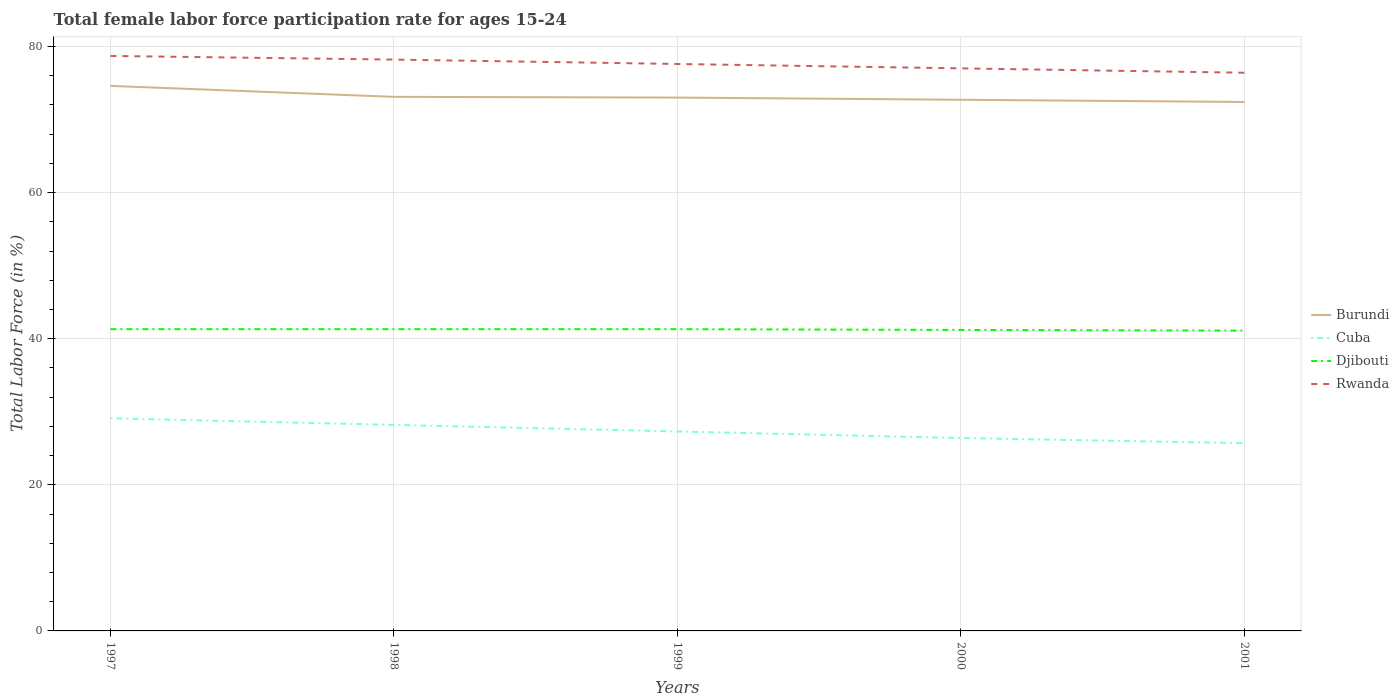Does the line corresponding to Cuba intersect with the line corresponding to Rwanda?
Ensure brevity in your answer.  No. Across all years, what is the maximum female labor force participation rate in Rwanda?
Give a very brief answer. 76.4. What is the total female labor force participation rate in Djibouti in the graph?
Offer a very short reply. 0.1. What is the difference between the highest and the second highest female labor force participation rate in Djibouti?
Give a very brief answer. 0.2. What is the difference between the highest and the lowest female labor force participation rate in Burundi?
Your answer should be very brief. 1. How many years are there in the graph?
Give a very brief answer. 5. Are the values on the major ticks of Y-axis written in scientific E-notation?
Provide a short and direct response. No. Does the graph contain grids?
Provide a short and direct response. Yes. How are the legend labels stacked?
Make the answer very short. Vertical. What is the title of the graph?
Your answer should be compact. Total female labor force participation rate for ages 15-24. Does "Ecuador" appear as one of the legend labels in the graph?
Provide a short and direct response. No. What is the label or title of the X-axis?
Your response must be concise. Years. What is the Total Labor Force (in %) in Burundi in 1997?
Keep it short and to the point. 74.6. What is the Total Labor Force (in %) of Cuba in 1997?
Offer a very short reply. 29.1. What is the Total Labor Force (in %) in Djibouti in 1997?
Provide a short and direct response. 41.3. What is the Total Labor Force (in %) in Rwanda in 1997?
Give a very brief answer. 78.7. What is the Total Labor Force (in %) in Burundi in 1998?
Your answer should be very brief. 73.1. What is the Total Labor Force (in %) of Cuba in 1998?
Keep it short and to the point. 28.2. What is the Total Labor Force (in %) of Djibouti in 1998?
Make the answer very short. 41.3. What is the Total Labor Force (in %) of Rwanda in 1998?
Make the answer very short. 78.2. What is the Total Labor Force (in %) in Burundi in 1999?
Provide a short and direct response. 73. What is the Total Labor Force (in %) of Cuba in 1999?
Provide a succinct answer. 27.3. What is the Total Labor Force (in %) in Djibouti in 1999?
Your answer should be compact. 41.3. What is the Total Labor Force (in %) in Rwanda in 1999?
Offer a terse response. 77.6. What is the Total Labor Force (in %) in Burundi in 2000?
Provide a short and direct response. 72.7. What is the Total Labor Force (in %) of Cuba in 2000?
Make the answer very short. 26.4. What is the Total Labor Force (in %) in Djibouti in 2000?
Your answer should be very brief. 41.2. What is the Total Labor Force (in %) of Rwanda in 2000?
Give a very brief answer. 77. What is the Total Labor Force (in %) in Burundi in 2001?
Your response must be concise. 72.4. What is the Total Labor Force (in %) in Cuba in 2001?
Give a very brief answer. 25.7. What is the Total Labor Force (in %) in Djibouti in 2001?
Provide a short and direct response. 41.1. What is the Total Labor Force (in %) of Rwanda in 2001?
Give a very brief answer. 76.4. Across all years, what is the maximum Total Labor Force (in %) of Burundi?
Give a very brief answer. 74.6. Across all years, what is the maximum Total Labor Force (in %) in Cuba?
Offer a very short reply. 29.1. Across all years, what is the maximum Total Labor Force (in %) in Djibouti?
Your answer should be compact. 41.3. Across all years, what is the maximum Total Labor Force (in %) in Rwanda?
Make the answer very short. 78.7. Across all years, what is the minimum Total Labor Force (in %) in Burundi?
Provide a succinct answer. 72.4. Across all years, what is the minimum Total Labor Force (in %) of Cuba?
Keep it short and to the point. 25.7. Across all years, what is the minimum Total Labor Force (in %) in Djibouti?
Your answer should be compact. 41.1. Across all years, what is the minimum Total Labor Force (in %) of Rwanda?
Ensure brevity in your answer.  76.4. What is the total Total Labor Force (in %) in Burundi in the graph?
Provide a succinct answer. 365.8. What is the total Total Labor Force (in %) in Cuba in the graph?
Provide a succinct answer. 136.7. What is the total Total Labor Force (in %) in Djibouti in the graph?
Keep it short and to the point. 206.2. What is the total Total Labor Force (in %) of Rwanda in the graph?
Give a very brief answer. 387.9. What is the difference between the Total Labor Force (in %) of Burundi in 1997 and that in 1998?
Your answer should be compact. 1.5. What is the difference between the Total Labor Force (in %) in Cuba in 1997 and that in 1998?
Give a very brief answer. 0.9. What is the difference between the Total Labor Force (in %) in Djibouti in 1997 and that in 1998?
Keep it short and to the point. 0. What is the difference between the Total Labor Force (in %) in Rwanda in 1997 and that in 1998?
Keep it short and to the point. 0.5. What is the difference between the Total Labor Force (in %) in Cuba in 1997 and that in 1999?
Give a very brief answer. 1.8. What is the difference between the Total Labor Force (in %) in Rwanda in 1997 and that in 1999?
Your response must be concise. 1.1. What is the difference between the Total Labor Force (in %) of Burundi in 1997 and that in 2000?
Make the answer very short. 1.9. What is the difference between the Total Labor Force (in %) of Cuba in 1997 and that in 2000?
Your response must be concise. 2.7. What is the difference between the Total Labor Force (in %) of Rwanda in 1997 and that in 2000?
Ensure brevity in your answer.  1.7. What is the difference between the Total Labor Force (in %) of Cuba in 1997 and that in 2001?
Give a very brief answer. 3.4. What is the difference between the Total Labor Force (in %) in Djibouti in 1997 and that in 2001?
Provide a short and direct response. 0.2. What is the difference between the Total Labor Force (in %) in Rwanda in 1997 and that in 2001?
Make the answer very short. 2.3. What is the difference between the Total Labor Force (in %) of Burundi in 1998 and that in 1999?
Provide a short and direct response. 0.1. What is the difference between the Total Labor Force (in %) in Burundi in 1998 and that in 2000?
Provide a succinct answer. 0.4. What is the difference between the Total Labor Force (in %) of Cuba in 1998 and that in 2001?
Give a very brief answer. 2.5. What is the difference between the Total Labor Force (in %) of Djibouti in 1998 and that in 2001?
Offer a very short reply. 0.2. What is the difference between the Total Labor Force (in %) of Cuba in 1999 and that in 2000?
Your answer should be compact. 0.9. What is the difference between the Total Labor Force (in %) of Djibouti in 1999 and that in 2000?
Provide a short and direct response. 0.1. What is the difference between the Total Labor Force (in %) of Burundi in 1999 and that in 2001?
Make the answer very short. 0.6. What is the difference between the Total Labor Force (in %) in Djibouti in 1999 and that in 2001?
Offer a terse response. 0.2. What is the difference between the Total Labor Force (in %) of Burundi in 2000 and that in 2001?
Keep it short and to the point. 0.3. What is the difference between the Total Labor Force (in %) in Rwanda in 2000 and that in 2001?
Make the answer very short. 0.6. What is the difference between the Total Labor Force (in %) of Burundi in 1997 and the Total Labor Force (in %) of Cuba in 1998?
Ensure brevity in your answer.  46.4. What is the difference between the Total Labor Force (in %) in Burundi in 1997 and the Total Labor Force (in %) in Djibouti in 1998?
Keep it short and to the point. 33.3. What is the difference between the Total Labor Force (in %) in Burundi in 1997 and the Total Labor Force (in %) in Rwanda in 1998?
Make the answer very short. -3.6. What is the difference between the Total Labor Force (in %) of Cuba in 1997 and the Total Labor Force (in %) of Djibouti in 1998?
Your answer should be very brief. -12.2. What is the difference between the Total Labor Force (in %) of Cuba in 1997 and the Total Labor Force (in %) of Rwanda in 1998?
Provide a succinct answer. -49.1. What is the difference between the Total Labor Force (in %) in Djibouti in 1997 and the Total Labor Force (in %) in Rwanda in 1998?
Give a very brief answer. -36.9. What is the difference between the Total Labor Force (in %) of Burundi in 1997 and the Total Labor Force (in %) of Cuba in 1999?
Provide a succinct answer. 47.3. What is the difference between the Total Labor Force (in %) in Burundi in 1997 and the Total Labor Force (in %) in Djibouti in 1999?
Make the answer very short. 33.3. What is the difference between the Total Labor Force (in %) in Burundi in 1997 and the Total Labor Force (in %) in Rwanda in 1999?
Offer a terse response. -3. What is the difference between the Total Labor Force (in %) of Cuba in 1997 and the Total Labor Force (in %) of Rwanda in 1999?
Make the answer very short. -48.5. What is the difference between the Total Labor Force (in %) of Djibouti in 1997 and the Total Labor Force (in %) of Rwanda in 1999?
Offer a very short reply. -36.3. What is the difference between the Total Labor Force (in %) in Burundi in 1997 and the Total Labor Force (in %) in Cuba in 2000?
Keep it short and to the point. 48.2. What is the difference between the Total Labor Force (in %) of Burundi in 1997 and the Total Labor Force (in %) of Djibouti in 2000?
Your response must be concise. 33.4. What is the difference between the Total Labor Force (in %) in Burundi in 1997 and the Total Labor Force (in %) in Rwanda in 2000?
Offer a very short reply. -2.4. What is the difference between the Total Labor Force (in %) of Cuba in 1997 and the Total Labor Force (in %) of Rwanda in 2000?
Offer a very short reply. -47.9. What is the difference between the Total Labor Force (in %) in Djibouti in 1997 and the Total Labor Force (in %) in Rwanda in 2000?
Ensure brevity in your answer.  -35.7. What is the difference between the Total Labor Force (in %) of Burundi in 1997 and the Total Labor Force (in %) of Cuba in 2001?
Give a very brief answer. 48.9. What is the difference between the Total Labor Force (in %) of Burundi in 1997 and the Total Labor Force (in %) of Djibouti in 2001?
Offer a very short reply. 33.5. What is the difference between the Total Labor Force (in %) in Burundi in 1997 and the Total Labor Force (in %) in Rwanda in 2001?
Keep it short and to the point. -1.8. What is the difference between the Total Labor Force (in %) of Cuba in 1997 and the Total Labor Force (in %) of Rwanda in 2001?
Your answer should be compact. -47.3. What is the difference between the Total Labor Force (in %) of Djibouti in 1997 and the Total Labor Force (in %) of Rwanda in 2001?
Give a very brief answer. -35.1. What is the difference between the Total Labor Force (in %) of Burundi in 1998 and the Total Labor Force (in %) of Cuba in 1999?
Your answer should be very brief. 45.8. What is the difference between the Total Labor Force (in %) in Burundi in 1998 and the Total Labor Force (in %) in Djibouti in 1999?
Ensure brevity in your answer.  31.8. What is the difference between the Total Labor Force (in %) of Burundi in 1998 and the Total Labor Force (in %) of Rwanda in 1999?
Keep it short and to the point. -4.5. What is the difference between the Total Labor Force (in %) of Cuba in 1998 and the Total Labor Force (in %) of Djibouti in 1999?
Provide a short and direct response. -13.1. What is the difference between the Total Labor Force (in %) in Cuba in 1998 and the Total Labor Force (in %) in Rwanda in 1999?
Offer a terse response. -49.4. What is the difference between the Total Labor Force (in %) in Djibouti in 1998 and the Total Labor Force (in %) in Rwanda in 1999?
Provide a succinct answer. -36.3. What is the difference between the Total Labor Force (in %) in Burundi in 1998 and the Total Labor Force (in %) in Cuba in 2000?
Keep it short and to the point. 46.7. What is the difference between the Total Labor Force (in %) of Burundi in 1998 and the Total Labor Force (in %) of Djibouti in 2000?
Offer a very short reply. 31.9. What is the difference between the Total Labor Force (in %) in Cuba in 1998 and the Total Labor Force (in %) in Djibouti in 2000?
Offer a terse response. -13. What is the difference between the Total Labor Force (in %) of Cuba in 1998 and the Total Labor Force (in %) of Rwanda in 2000?
Provide a succinct answer. -48.8. What is the difference between the Total Labor Force (in %) of Djibouti in 1998 and the Total Labor Force (in %) of Rwanda in 2000?
Your answer should be very brief. -35.7. What is the difference between the Total Labor Force (in %) in Burundi in 1998 and the Total Labor Force (in %) in Cuba in 2001?
Ensure brevity in your answer.  47.4. What is the difference between the Total Labor Force (in %) in Burundi in 1998 and the Total Labor Force (in %) in Djibouti in 2001?
Give a very brief answer. 32. What is the difference between the Total Labor Force (in %) of Burundi in 1998 and the Total Labor Force (in %) of Rwanda in 2001?
Offer a terse response. -3.3. What is the difference between the Total Labor Force (in %) of Cuba in 1998 and the Total Labor Force (in %) of Djibouti in 2001?
Ensure brevity in your answer.  -12.9. What is the difference between the Total Labor Force (in %) of Cuba in 1998 and the Total Labor Force (in %) of Rwanda in 2001?
Offer a very short reply. -48.2. What is the difference between the Total Labor Force (in %) in Djibouti in 1998 and the Total Labor Force (in %) in Rwanda in 2001?
Your answer should be very brief. -35.1. What is the difference between the Total Labor Force (in %) of Burundi in 1999 and the Total Labor Force (in %) of Cuba in 2000?
Keep it short and to the point. 46.6. What is the difference between the Total Labor Force (in %) in Burundi in 1999 and the Total Labor Force (in %) in Djibouti in 2000?
Your response must be concise. 31.8. What is the difference between the Total Labor Force (in %) in Cuba in 1999 and the Total Labor Force (in %) in Djibouti in 2000?
Provide a short and direct response. -13.9. What is the difference between the Total Labor Force (in %) in Cuba in 1999 and the Total Labor Force (in %) in Rwanda in 2000?
Ensure brevity in your answer.  -49.7. What is the difference between the Total Labor Force (in %) of Djibouti in 1999 and the Total Labor Force (in %) of Rwanda in 2000?
Your response must be concise. -35.7. What is the difference between the Total Labor Force (in %) of Burundi in 1999 and the Total Labor Force (in %) of Cuba in 2001?
Provide a short and direct response. 47.3. What is the difference between the Total Labor Force (in %) of Burundi in 1999 and the Total Labor Force (in %) of Djibouti in 2001?
Offer a terse response. 31.9. What is the difference between the Total Labor Force (in %) in Cuba in 1999 and the Total Labor Force (in %) in Djibouti in 2001?
Offer a very short reply. -13.8. What is the difference between the Total Labor Force (in %) of Cuba in 1999 and the Total Labor Force (in %) of Rwanda in 2001?
Your answer should be compact. -49.1. What is the difference between the Total Labor Force (in %) in Djibouti in 1999 and the Total Labor Force (in %) in Rwanda in 2001?
Give a very brief answer. -35.1. What is the difference between the Total Labor Force (in %) of Burundi in 2000 and the Total Labor Force (in %) of Djibouti in 2001?
Your answer should be compact. 31.6. What is the difference between the Total Labor Force (in %) in Cuba in 2000 and the Total Labor Force (in %) in Djibouti in 2001?
Provide a succinct answer. -14.7. What is the difference between the Total Labor Force (in %) of Djibouti in 2000 and the Total Labor Force (in %) of Rwanda in 2001?
Provide a succinct answer. -35.2. What is the average Total Labor Force (in %) of Burundi per year?
Make the answer very short. 73.16. What is the average Total Labor Force (in %) of Cuba per year?
Make the answer very short. 27.34. What is the average Total Labor Force (in %) of Djibouti per year?
Your answer should be very brief. 41.24. What is the average Total Labor Force (in %) in Rwanda per year?
Offer a terse response. 77.58. In the year 1997, what is the difference between the Total Labor Force (in %) of Burundi and Total Labor Force (in %) of Cuba?
Keep it short and to the point. 45.5. In the year 1997, what is the difference between the Total Labor Force (in %) in Burundi and Total Labor Force (in %) in Djibouti?
Give a very brief answer. 33.3. In the year 1997, what is the difference between the Total Labor Force (in %) of Burundi and Total Labor Force (in %) of Rwanda?
Provide a succinct answer. -4.1. In the year 1997, what is the difference between the Total Labor Force (in %) of Cuba and Total Labor Force (in %) of Djibouti?
Keep it short and to the point. -12.2. In the year 1997, what is the difference between the Total Labor Force (in %) of Cuba and Total Labor Force (in %) of Rwanda?
Your answer should be compact. -49.6. In the year 1997, what is the difference between the Total Labor Force (in %) in Djibouti and Total Labor Force (in %) in Rwanda?
Offer a very short reply. -37.4. In the year 1998, what is the difference between the Total Labor Force (in %) in Burundi and Total Labor Force (in %) in Cuba?
Give a very brief answer. 44.9. In the year 1998, what is the difference between the Total Labor Force (in %) in Burundi and Total Labor Force (in %) in Djibouti?
Provide a succinct answer. 31.8. In the year 1998, what is the difference between the Total Labor Force (in %) of Djibouti and Total Labor Force (in %) of Rwanda?
Provide a short and direct response. -36.9. In the year 1999, what is the difference between the Total Labor Force (in %) in Burundi and Total Labor Force (in %) in Cuba?
Provide a succinct answer. 45.7. In the year 1999, what is the difference between the Total Labor Force (in %) in Burundi and Total Labor Force (in %) in Djibouti?
Keep it short and to the point. 31.7. In the year 1999, what is the difference between the Total Labor Force (in %) of Cuba and Total Labor Force (in %) of Djibouti?
Your answer should be very brief. -14. In the year 1999, what is the difference between the Total Labor Force (in %) of Cuba and Total Labor Force (in %) of Rwanda?
Make the answer very short. -50.3. In the year 1999, what is the difference between the Total Labor Force (in %) in Djibouti and Total Labor Force (in %) in Rwanda?
Keep it short and to the point. -36.3. In the year 2000, what is the difference between the Total Labor Force (in %) of Burundi and Total Labor Force (in %) of Cuba?
Provide a short and direct response. 46.3. In the year 2000, what is the difference between the Total Labor Force (in %) in Burundi and Total Labor Force (in %) in Djibouti?
Ensure brevity in your answer.  31.5. In the year 2000, what is the difference between the Total Labor Force (in %) of Burundi and Total Labor Force (in %) of Rwanda?
Keep it short and to the point. -4.3. In the year 2000, what is the difference between the Total Labor Force (in %) of Cuba and Total Labor Force (in %) of Djibouti?
Provide a succinct answer. -14.8. In the year 2000, what is the difference between the Total Labor Force (in %) in Cuba and Total Labor Force (in %) in Rwanda?
Provide a succinct answer. -50.6. In the year 2000, what is the difference between the Total Labor Force (in %) of Djibouti and Total Labor Force (in %) of Rwanda?
Ensure brevity in your answer.  -35.8. In the year 2001, what is the difference between the Total Labor Force (in %) of Burundi and Total Labor Force (in %) of Cuba?
Offer a very short reply. 46.7. In the year 2001, what is the difference between the Total Labor Force (in %) of Burundi and Total Labor Force (in %) of Djibouti?
Provide a succinct answer. 31.3. In the year 2001, what is the difference between the Total Labor Force (in %) of Burundi and Total Labor Force (in %) of Rwanda?
Ensure brevity in your answer.  -4. In the year 2001, what is the difference between the Total Labor Force (in %) of Cuba and Total Labor Force (in %) of Djibouti?
Your answer should be compact. -15.4. In the year 2001, what is the difference between the Total Labor Force (in %) in Cuba and Total Labor Force (in %) in Rwanda?
Offer a very short reply. -50.7. In the year 2001, what is the difference between the Total Labor Force (in %) in Djibouti and Total Labor Force (in %) in Rwanda?
Give a very brief answer. -35.3. What is the ratio of the Total Labor Force (in %) of Burundi in 1997 to that in 1998?
Your answer should be very brief. 1.02. What is the ratio of the Total Labor Force (in %) of Cuba in 1997 to that in 1998?
Make the answer very short. 1.03. What is the ratio of the Total Labor Force (in %) of Djibouti in 1997 to that in 1998?
Ensure brevity in your answer.  1. What is the ratio of the Total Labor Force (in %) in Rwanda in 1997 to that in 1998?
Your answer should be compact. 1.01. What is the ratio of the Total Labor Force (in %) of Burundi in 1997 to that in 1999?
Your response must be concise. 1.02. What is the ratio of the Total Labor Force (in %) of Cuba in 1997 to that in 1999?
Provide a short and direct response. 1.07. What is the ratio of the Total Labor Force (in %) in Rwanda in 1997 to that in 1999?
Your answer should be compact. 1.01. What is the ratio of the Total Labor Force (in %) in Burundi in 1997 to that in 2000?
Offer a terse response. 1.03. What is the ratio of the Total Labor Force (in %) in Cuba in 1997 to that in 2000?
Your answer should be very brief. 1.1. What is the ratio of the Total Labor Force (in %) in Rwanda in 1997 to that in 2000?
Offer a terse response. 1.02. What is the ratio of the Total Labor Force (in %) in Burundi in 1997 to that in 2001?
Your answer should be compact. 1.03. What is the ratio of the Total Labor Force (in %) of Cuba in 1997 to that in 2001?
Ensure brevity in your answer.  1.13. What is the ratio of the Total Labor Force (in %) of Rwanda in 1997 to that in 2001?
Your response must be concise. 1.03. What is the ratio of the Total Labor Force (in %) in Cuba in 1998 to that in 1999?
Provide a short and direct response. 1.03. What is the ratio of the Total Labor Force (in %) in Djibouti in 1998 to that in 1999?
Offer a very short reply. 1. What is the ratio of the Total Labor Force (in %) in Rwanda in 1998 to that in 1999?
Provide a short and direct response. 1.01. What is the ratio of the Total Labor Force (in %) of Burundi in 1998 to that in 2000?
Give a very brief answer. 1.01. What is the ratio of the Total Labor Force (in %) of Cuba in 1998 to that in 2000?
Offer a terse response. 1.07. What is the ratio of the Total Labor Force (in %) of Djibouti in 1998 to that in 2000?
Ensure brevity in your answer.  1. What is the ratio of the Total Labor Force (in %) in Rwanda in 1998 to that in 2000?
Make the answer very short. 1.02. What is the ratio of the Total Labor Force (in %) of Burundi in 1998 to that in 2001?
Offer a terse response. 1.01. What is the ratio of the Total Labor Force (in %) of Cuba in 1998 to that in 2001?
Give a very brief answer. 1.1. What is the ratio of the Total Labor Force (in %) in Djibouti in 1998 to that in 2001?
Give a very brief answer. 1. What is the ratio of the Total Labor Force (in %) of Rwanda in 1998 to that in 2001?
Provide a short and direct response. 1.02. What is the ratio of the Total Labor Force (in %) of Burundi in 1999 to that in 2000?
Make the answer very short. 1. What is the ratio of the Total Labor Force (in %) of Cuba in 1999 to that in 2000?
Your response must be concise. 1.03. What is the ratio of the Total Labor Force (in %) of Djibouti in 1999 to that in 2000?
Ensure brevity in your answer.  1. What is the ratio of the Total Labor Force (in %) in Burundi in 1999 to that in 2001?
Offer a terse response. 1.01. What is the ratio of the Total Labor Force (in %) in Cuba in 1999 to that in 2001?
Provide a succinct answer. 1.06. What is the ratio of the Total Labor Force (in %) of Djibouti in 1999 to that in 2001?
Offer a terse response. 1. What is the ratio of the Total Labor Force (in %) in Rwanda in 1999 to that in 2001?
Your response must be concise. 1.02. What is the ratio of the Total Labor Force (in %) of Burundi in 2000 to that in 2001?
Your answer should be compact. 1. What is the ratio of the Total Labor Force (in %) in Cuba in 2000 to that in 2001?
Make the answer very short. 1.03. What is the ratio of the Total Labor Force (in %) of Djibouti in 2000 to that in 2001?
Make the answer very short. 1. What is the ratio of the Total Labor Force (in %) in Rwanda in 2000 to that in 2001?
Your answer should be compact. 1.01. What is the difference between the highest and the lowest Total Labor Force (in %) in Cuba?
Ensure brevity in your answer.  3.4. What is the difference between the highest and the lowest Total Labor Force (in %) of Rwanda?
Your answer should be compact. 2.3. 